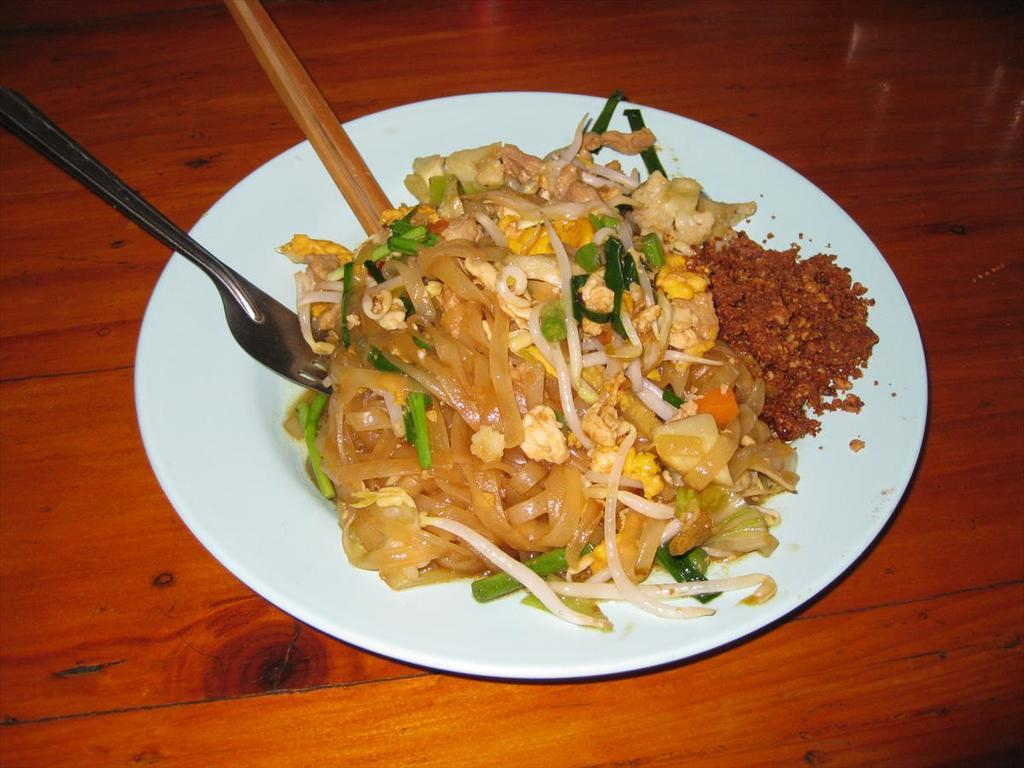What utensils are visible in the image? There is a fork and chopsticks in the image. What type of food is on the plate in the image? There is fast food on a plate in the image. Where is the plate located in the image? The plate is on a table. What song is the girl singing in the image? There is no girl or song present in the image. 